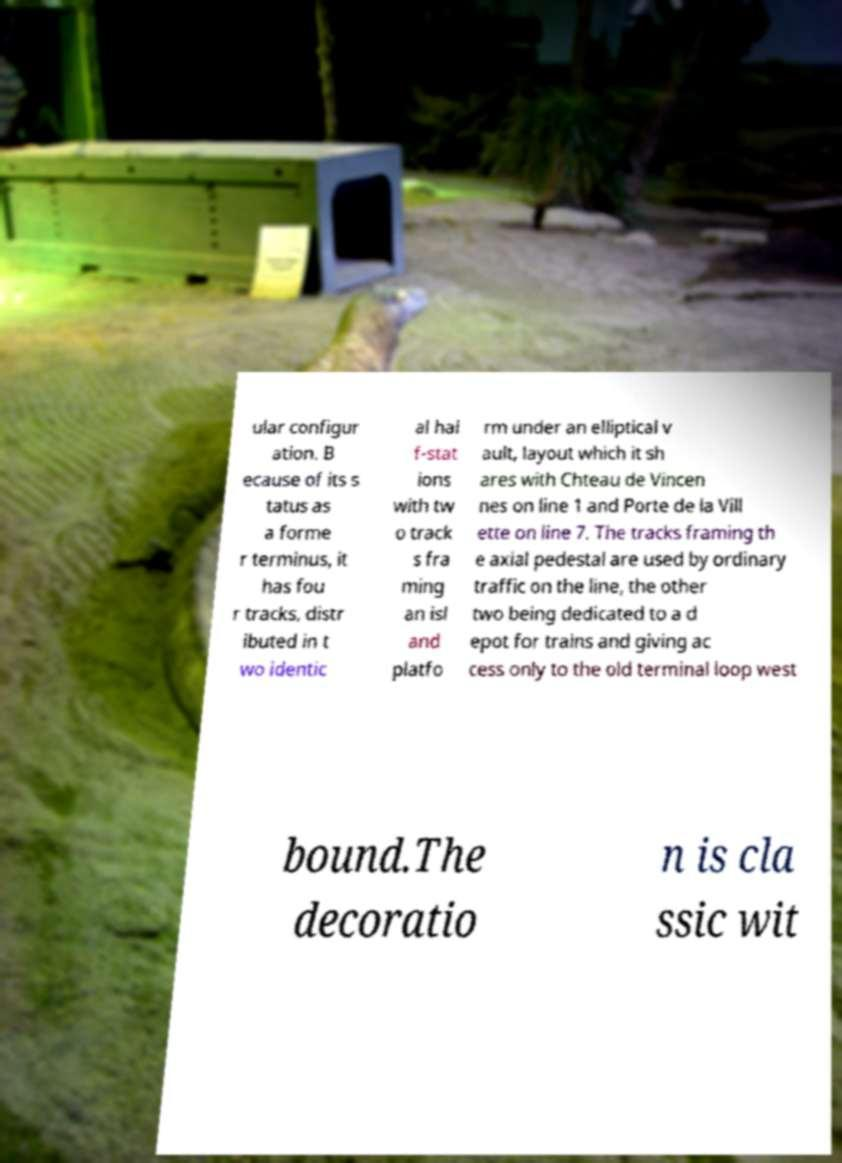Could you assist in decoding the text presented in this image and type it out clearly? ular configur ation. B ecause of its s tatus as a forme r terminus, it has fou r tracks, distr ibuted in t wo identic al hal f-stat ions with tw o track s fra ming an isl and platfo rm under an elliptical v ault, layout which it sh ares with Chteau de Vincen nes on line 1 and Porte de la Vill ette on line 7. The tracks framing th e axial pedestal are used by ordinary traffic on the line, the other two being dedicated to a d epot for trains and giving ac cess only to the old terminal loop west bound.The decoratio n is cla ssic wit 